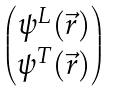Convert formula to latex. <formula><loc_0><loc_0><loc_500><loc_500>\begin{pmatrix} \psi ^ { L } ( \vec { r } ) \\ \psi ^ { T } ( \vec { r } ) \end{pmatrix}</formula> 